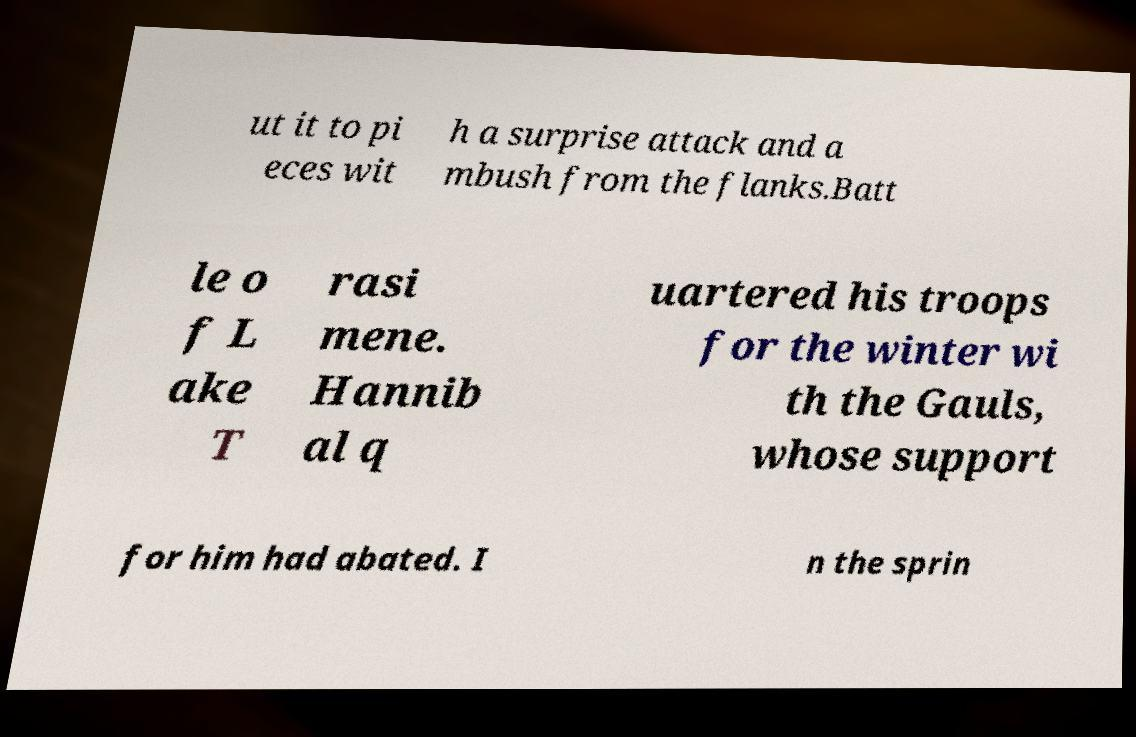I need the written content from this picture converted into text. Can you do that? ut it to pi eces wit h a surprise attack and a mbush from the flanks.Batt le o f L ake T rasi mene. Hannib al q uartered his troops for the winter wi th the Gauls, whose support for him had abated. I n the sprin 